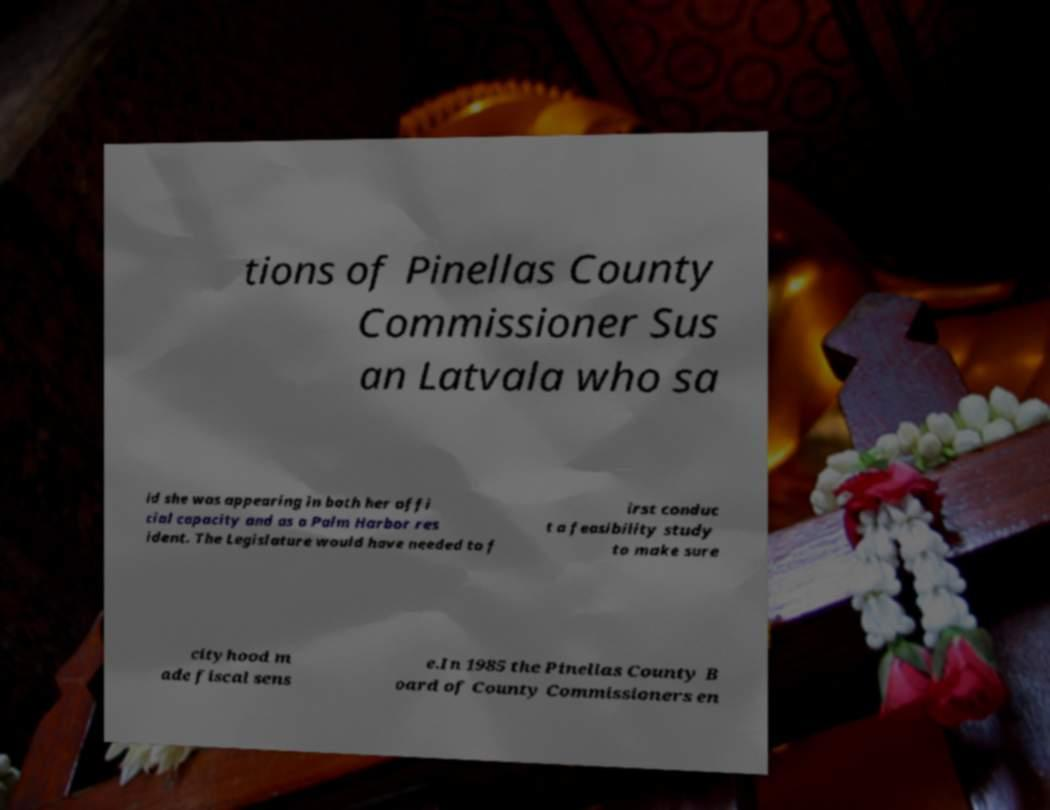What messages or text are displayed in this image? I need them in a readable, typed format. tions of Pinellas County Commissioner Sus an Latvala who sa id she was appearing in both her offi cial capacity and as a Palm Harbor res ident. The Legislature would have needed to f irst conduc t a feasibility study to make sure cityhood m ade fiscal sens e.In 1985 the Pinellas County B oard of County Commissioners en 